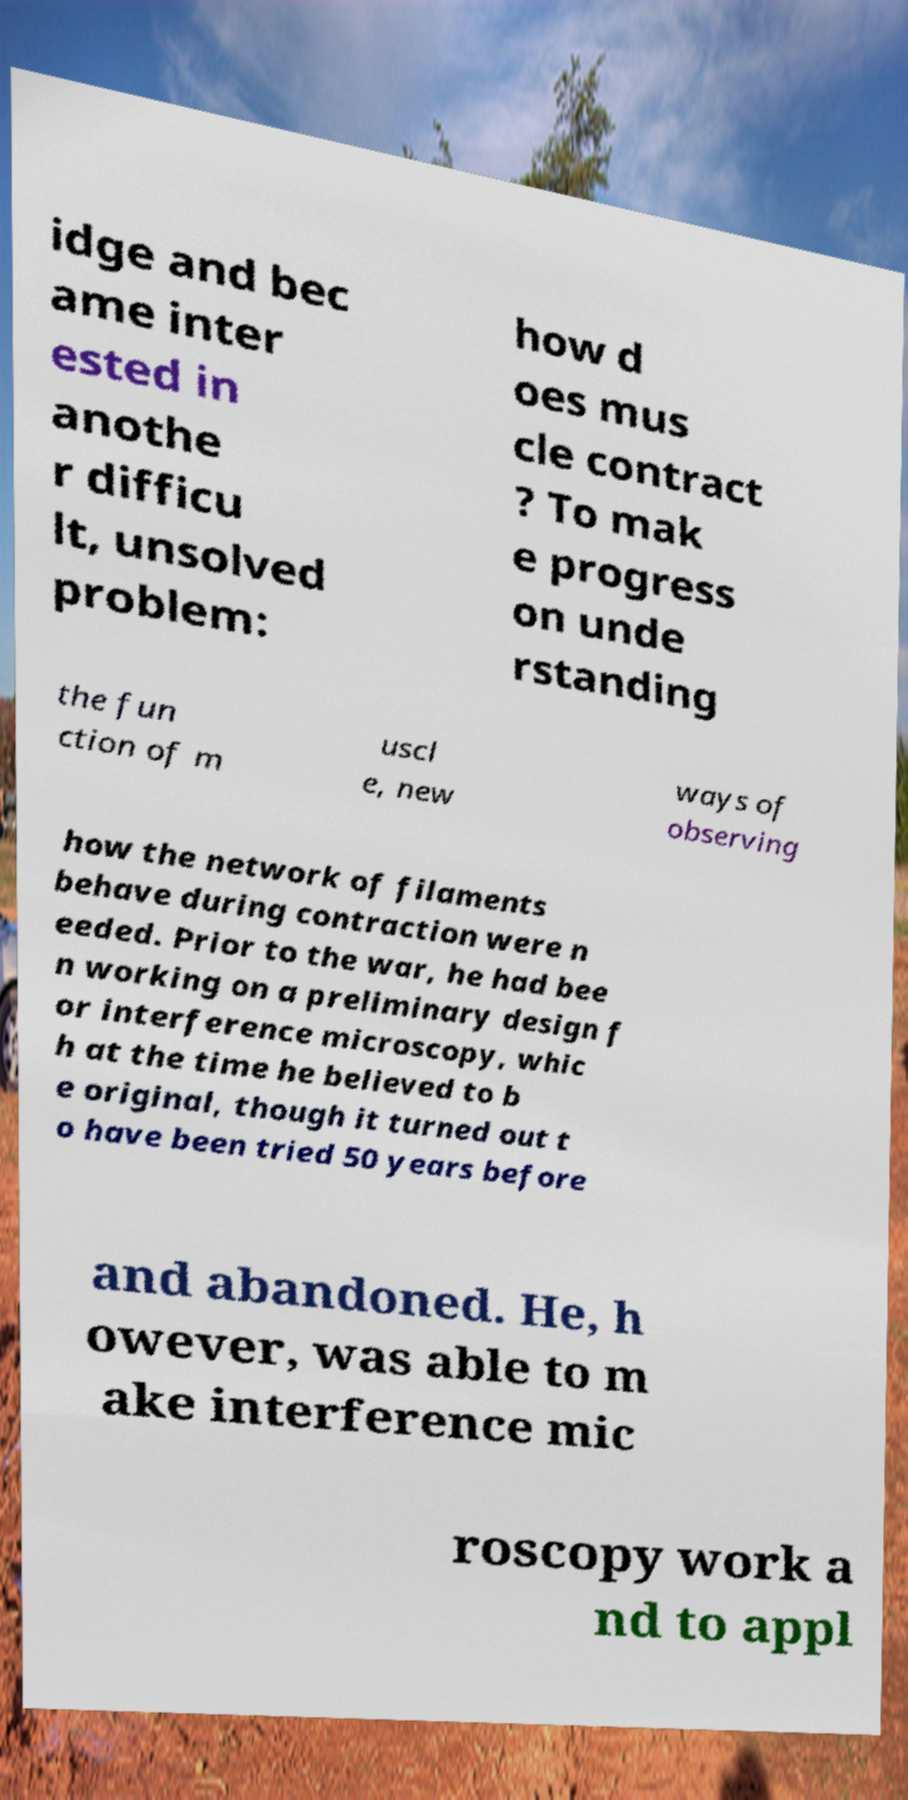Could you assist in decoding the text presented in this image and type it out clearly? idge and bec ame inter ested in anothe r difficu lt, unsolved problem: how d oes mus cle contract ? To mak e progress on unde rstanding the fun ction of m uscl e, new ways of observing how the network of filaments behave during contraction were n eeded. Prior to the war, he had bee n working on a preliminary design f or interference microscopy, whic h at the time he believed to b e original, though it turned out t o have been tried 50 years before and abandoned. He, h owever, was able to m ake interference mic roscopy work a nd to appl 